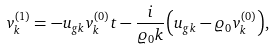<formula> <loc_0><loc_0><loc_500><loc_500>v _ { k } ^ { ( 1 ) } = - u _ { g k } v _ { k } ^ { ( 0 ) } t - { \frac { i } { \varrho _ { 0 } k } } { \left ( u _ { g k } - \varrho _ { 0 } v _ { k } ^ { ( 0 ) } \right ) } ,</formula> 